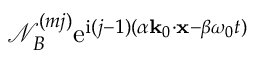Convert formula to latex. <formula><loc_0><loc_0><loc_500><loc_500>\mathcal { N } _ { B } ^ { ( m j ) } e ^ { i ( j - 1 ) ( \alpha k _ { 0 } \cdot x - \beta \omega _ { 0 } t ) }</formula> 